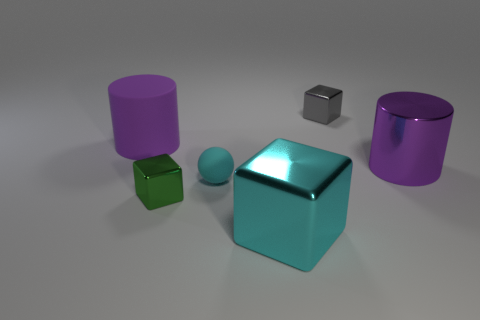Are there any other things that have the same shape as the cyan rubber thing?
Provide a succinct answer. No. Do the tiny gray thing and the purple shiny object have the same shape?
Your answer should be very brief. No. What is the size of the cyan object behind the cyan shiny block that is in front of the purple cylinder that is on the right side of the tiny gray object?
Keep it short and to the point. Small. There is a cyan object that is the same shape as the small gray object; what is it made of?
Offer a terse response. Metal. Is there anything else that is the same size as the gray cube?
Your answer should be compact. Yes. There is a purple cylinder on the right side of the purple rubber cylinder left of the cyan block; what size is it?
Your answer should be very brief. Large. What color is the matte sphere?
Ensure brevity in your answer.  Cyan. There is a tiny block in front of the purple matte object; how many blocks are to the right of it?
Your response must be concise. 2. Is there a purple matte cylinder to the right of the purple matte cylinder behind the tiny green shiny object?
Make the answer very short. No. There is a purple matte cylinder; are there any small cyan matte spheres left of it?
Provide a short and direct response. No. 